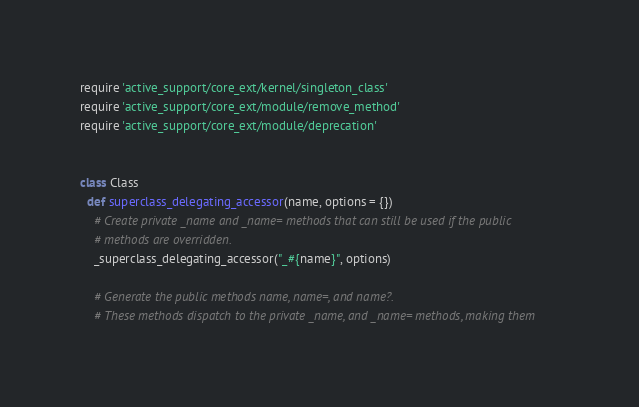<code> <loc_0><loc_0><loc_500><loc_500><_Ruby_>require 'active_support/core_ext/kernel/singleton_class'
require 'active_support/core_ext/module/remove_method'
require 'active_support/core_ext/module/deprecation'


class Class
  def superclass_delegating_accessor(name, options = {})
    # Create private _name and _name= methods that can still be used if the public
    # methods are overridden.
    _superclass_delegating_accessor("_#{name}", options)

    # Generate the public methods name, name=, and name?.
    # These methods dispatch to the private _name, and _name= methods, making them</code> 